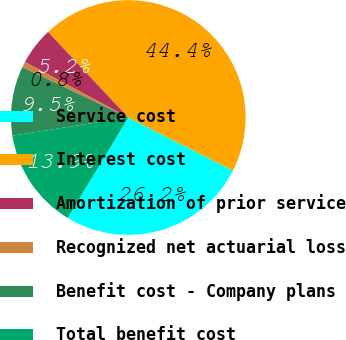<chart> <loc_0><loc_0><loc_500><loc_500><pie_chart><fcel>Service cost<fcel>Interest cost<fcel>Amortization of prior service<fcel>Recognized net actuarial loss<fcel>Benefit cost - Company plans<fcel>Total benefit cost<nl><fcel>26.18%<fcel>44.45%<fcel>5.16%<fcel>0.79%<fcel>9.53%<fcel>13.89%<nl></chart> 